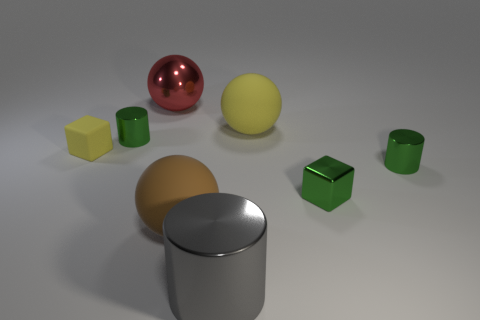Are there any big yellow matte things?
Your answer should be compact. Yes. Is the big brown object the same shape as the gray shiny object?
Offer a very short reply. No. What number of tiny objects are either purple blocks or yellow rubber spheres?
Give a very brief answer. 0. The metal block is what color?
Keep it short and to the point. Green. There is a big rubber object on the left side of the big metallic object that is right of the metallic ball; what shape is it?
Your answer should be compact. Sphere. Is there a yellow object made of the same material as the small yellow block?
Your response must be concise. Yes. There is a cylinder left of the red shiny object; is its size the same as the small yellow matte object?
Provide a short and direct response. Yes. How many green things are big things or things?
Make the answer very short. 3. What is the tiny cylinder in front of the tiny rubber thing made of?
Make the answer very short. Metal. There is a matte sphere behind the tiny green metal block; how many large gray shiny cylinders are right of it?
Your answer should be compact. 0. 